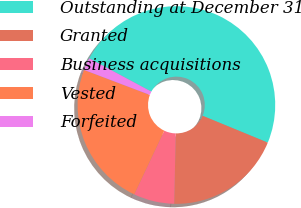Convert chart to OTSL. <chart><loc_0><loc_0><loc_500><loc_500><pie_chart><fcel>Outstanding at December 31<fcel>Granted<fcel>Business acquisitions<fcel>Vested<fcel>Forfeited<nl><fcel>48.4%<fcel>19.14%<fcel>6.66%<fcel>23.76%<fcel>2.04%<nl></chart> 